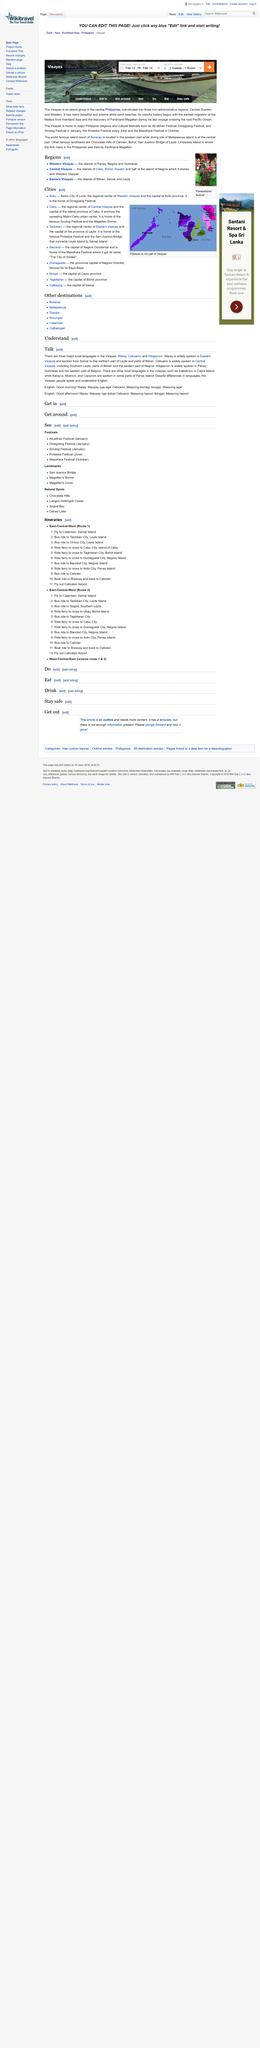Highlight a few significant elements in this photo. It is confirmed that "Good morning" and "Good afternoon" are translated into three local languages in the country. The Visayas region is home to three major local languages: Waray, Cebuano, and Hiligaynon. Cebuano is widely spoken in Central Visayas. 